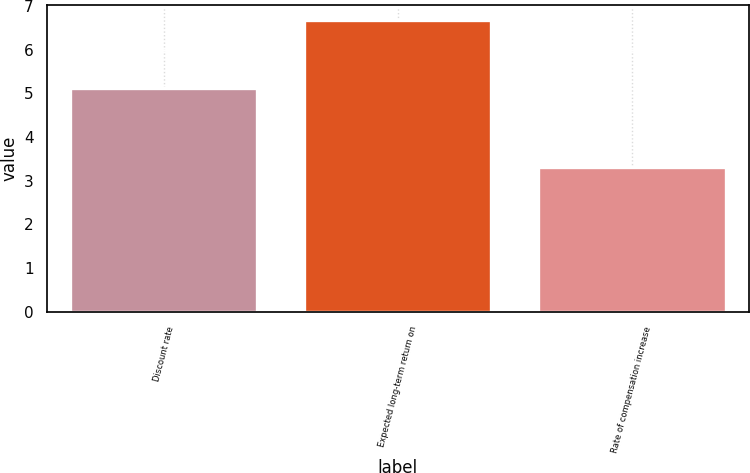Convert chart to OTSL. <chart><loc_0><loc_0><loc_500><loc_500><bar_chart><fcel>Discount rate<fcel>Expected long-term return on<fcel>Rate of compensation increase<nl><fcel>5.11<fcel>6.68<fcel>3.32<nl></chart> 